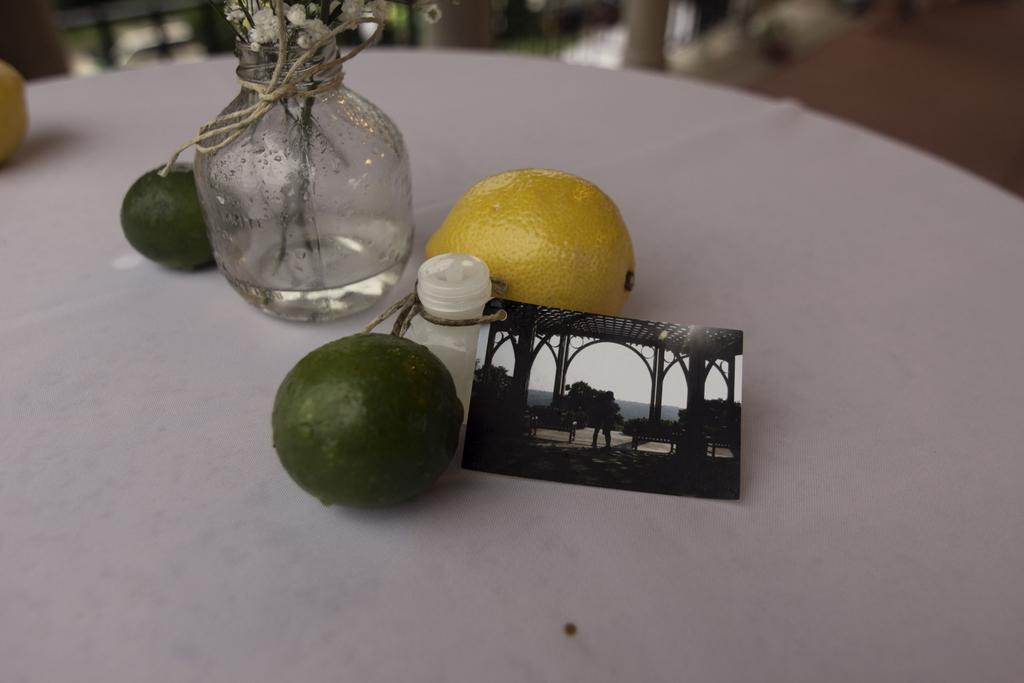What type of food items can be seen in the image? There are fruits in the image. What container is present in the image? There is a glass jar in the image. What color is the surface on which the objects are placed? The surface is white in color. Can you describe the background of the image? The background of the image is blurred. What type of hair can be seen on the fruits in the image? There is no hair present on the fruits in the image. 